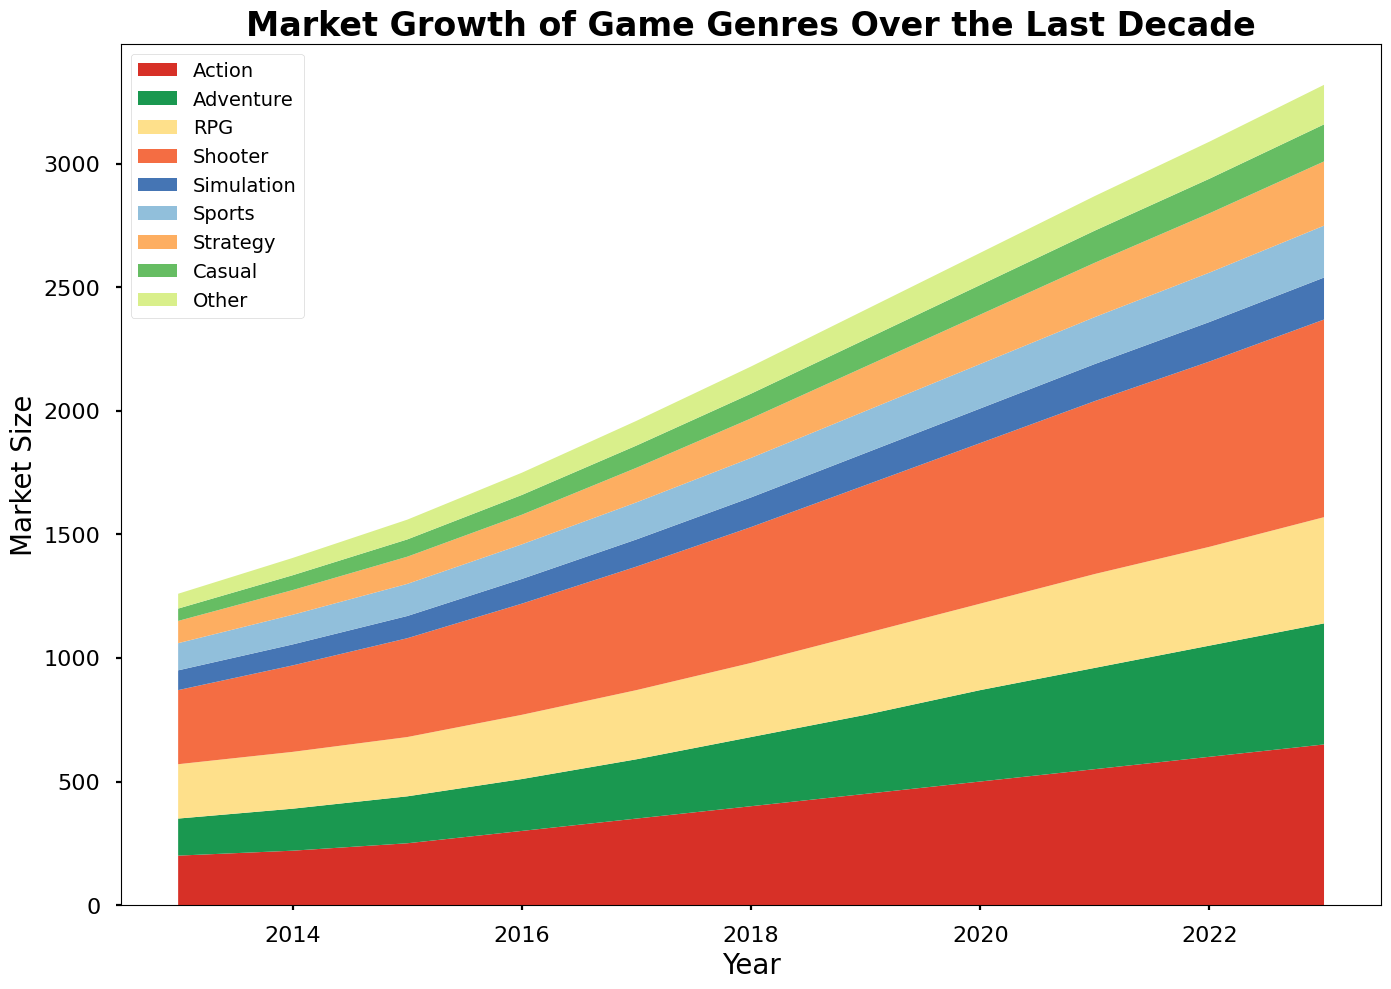What genre had the highest market size in 2023? In 2023, the genre with the widest and tallest area is the Shooter genre, making it the largest.
Answer: Shooter Which genre showed the most consistent growth each year? By observing the chart, the Shooter genre consistently increases its area each year without any decrease or plateau, indicating steady growth.
Answer: Shooter How did the market size of RPGs change from 2013 to 2023? Starting at 220 in 2013 and reaching 430 in 2023, the RPG market size increased by (430 - 220) = 210 over the decade.
Answer: 210 Between 2018 and 2020, which genre saw the largest increase in market size? Comparing the areas for each genre between 2018 and 2020, Shooter grew from 550 to 650, an increase of 100, which is the largest among all genres.
Answer: Shooter What is the total market size for Casual and Simulation genres combined in 2022? By adding the market size of Casual (140) and Simulation (160) in 2022, we get (140 + 160) = 300.
Answer: 300 Which genre had the smallest market size in 2015? The Casual genre has the smallest area in 2015, representing the lowest market size.
Answer: Casual Compare the market growth of the Action and RPG genres between 2013 and 2023. Which had more growth? Action grew from 200 to 650 (growth of 450), while RPG grew from 220 to 430 (growth of 210). Hence, Action had more growth.
Answer: Action What is the approximate total market size for all genres combined in 2023? Adding the market sizes of all genres in 2023: 650 + 490 + 430 + 800 + 170 + 210 + 260 + 150 + 160 = 3320.
Answer: 3320 Which genre had the highest market size in the mid-point of the dataset (2018)? In 2018, the Shooter genre has the widest and tallest area, indicating it had the highest market size.
Answer: Shooter What trend can be observed in the market size of the Strategy genre over the decade? The Strategy genre shows a consistent increase in market size over the years, from 90 in 2013 to 260 in 2023.
Answer: Consistent increase 